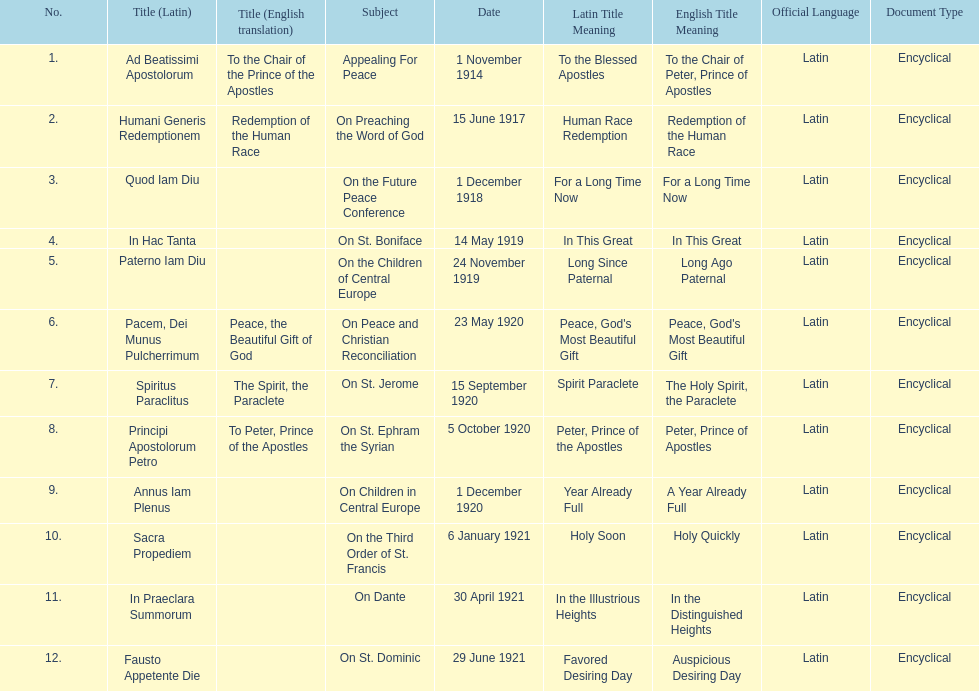What was the number of encyclopedias that had subjects relating specifically to children? 2. 